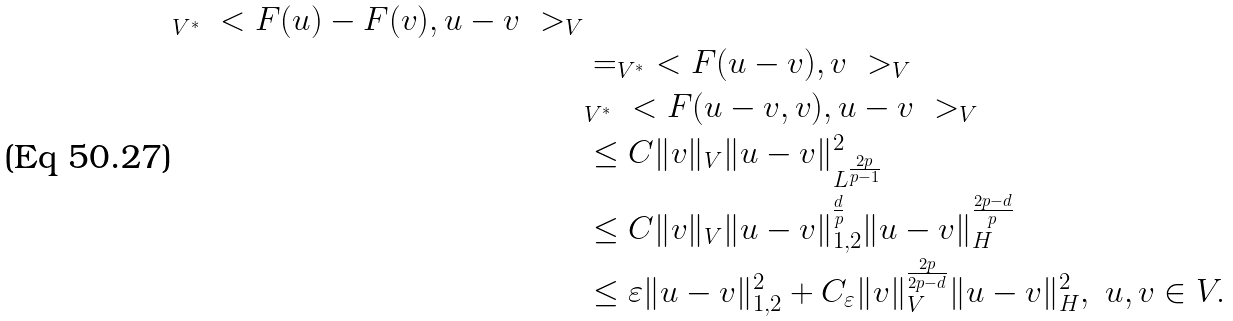<formula> <loc_0><loc_0><loc_500><loc_500>_ { V ^ { * } } \ < F ( u ) - F ( v ) , u - v \ > _ { V } \\ & = _ { V ^ { * } } \ < F ( u - v ) , v \ > _ { V } \\ & _ { V ^ { * } } \ < F ( u - v , v ) , u - v \ > _ { V } \\ & \leq C \| v \| _ { V } \| u - v \| _ { L ^ { \frac { 2 p } { p - 1 } } } ^ { 2 } \\ & \leq C \| v \| _ { V } \| u - v \| _ { 1 , 2 } ^ { \frac { d } { p } } \| u - v \| _ { H } ^ { \frac { 2 p - d } { p } } \\ & \leq \varepsilon \| u - v \| _ { 1 , 2 } ^ { 2 } + C _ { \varepsilon } \| v \| _ { V } ^ { \frac { 2 p } { 2 p - d } } \| u - v \| _ { H } ^ { 2 } , \ u , v \in V .</formula> 